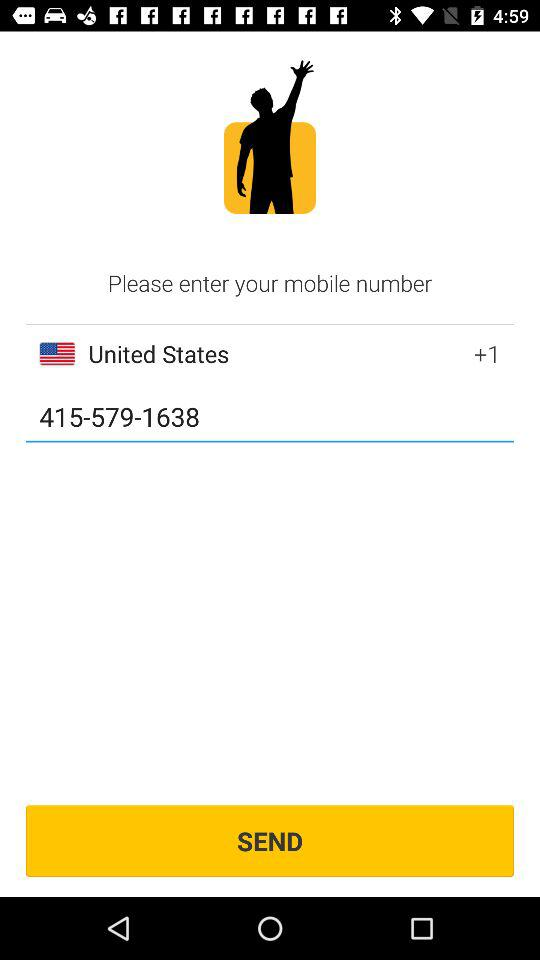What is the country code of the United States? The country code of the United States is +1. 